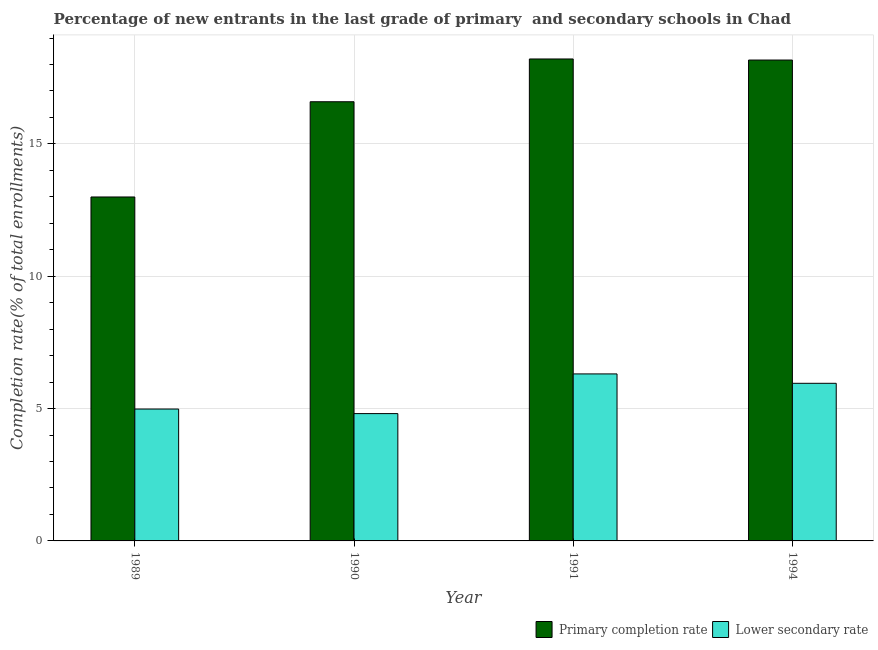How many different coloured bars are there?
Offer a terse response. 2. How many groups of bars are there?
Ensure brevity in your answer.  4. Are the number of bars per tick equal to the number of legend labels?
Give a very brief answer. Yes. How many bars are there on the 2nd tick from the left?
Make the answer very short. 2. How many bars are there on the 2nd tick from the right?
Keep it short and to the point. 2. What is the label of the 3rd group of bars from the left?
Offer a very short reply. 1991. What is the completion rate in primary schools in 1989?
Give a very brief answer. 13. Across all years, what is the maximum completion rate in secondary schools?
Offer a terse response. 6.31. Across all years, what is the minimum completion rate in secondary schools?
Your answer should be compact. 4.81. In which year was the completion rate in secondary schools maximum?
Give a very brief answer. 1991. In which year was the completion rate in secondary schools minimum?
Offer a very short reply. 1990. What is the total completion rate in primary schools in the graph?
Provide a succinct answer. 65.97. What is the difference between the completion rate in secondary schools in 1989 and that in 1994?
Keep it short and to the point. -0.97. What is the difference between the completion rate in primary schools in 1990 and the completion rate in secondary schools in 1991?
Your answer should be compact. -1.62. What is the average completion rate in secondary schools per year?
Provide a short and direct response. 5.51. In how many years, is the completion rate in secondary schools greater than 16 %?
Provide a succinct answer. 0. What is the ratio of the completion rate in secondary schools in 1989 to that in 1990?
Ensure brevity in your answer.  1.04. Is the difference between the completion rate in primary schools in 1990 and 1994 greater than the difference between the completion rate in secondary schools in 1990 and 1994?
Your response must be concise. No. What is the difference between the highest and the second highest completion rate in secondary schools?
Provide a short and direct response. 0.36. What is the difference between the highest and the lowest completion rate in primary schools?
Make the answer very short. 5.21. In how many years, is the completion rate in primary schools greater than the average completion rate in primary schools taken over all years?
Ensure brevity in your answer.  3. Is the sum of the completion rate in primary schools in 1989 and 1990 greater than the maximum completion rate in secondary schools across all years?
Your answer should be very brief. Yes. What does the 2nd bar from the left in 1994 represents?
Your answer should be compact. Lower secondary rate. What does the 1st bar from the right in 1994 represents?
Keep it short and to the point. Lower secondary rate. How many bars are there?
Provide a short and direct response. 8. Are all the bars in the graph horizontal?
Give a very brief answer. No. How many years are there in the graph?
Make the answer very short. 4. What is the difference between two consecutive major ticks on the Y-axis?
Your response must be concise. 5. Are the values on the major ticks of Y-axis written in scientific E-notation?
Make the answer very short. No. Does the graph contain any zero values?
Offer a terse response. No. Where does the legend appear in the graph?
Provide a short and direct response. Bottom right. How many legend labels are there?
Your answer should be compact. 2. What is the title of the graph?
Your answer should be very brief. Percentage of new entrants in the last grade of primary  and secondary schools in Chad. Does "Excluding technical cooperation" appear as one of the legend labels in the graph?
Provide a short and direct response. No. What is the label or title of the X-axis?
Give a very brief answer. Year. What is the label or title of the Y-axis?
Ensure brevity in your answer.  Completion rate(% of total enrollments). What is the Completion rate(% of total enrollments) of Primary completion rate in 1989?
Your answer should be compact. 13. What is the Completion rate(% of total enrollments) of Lower secondary rate in 1989?
Your answer should be compact. 4.98. What is the Completion rate(% of total enrollments) of Primary completion rate in 1990?
Your answer should be very brief. 16.59. What is the Completion rate(% of total enrollments) in Lower secondary rate in 1990?
Your answer should be very brief. 4.81. What is the Completion rate(% of total enrollments) in Primary completion rate in 1991?
Provide a succinct answer. 18.21. What is the Completion rate(% of total enrollments) in Lower secondary rate in 1991?
Keep it short and to the point. 6.31. What is the Completion rate(% of total enrollments) in Primary completion rate in 1994?
Keep it short and to the point. 18.17. What is the Completion rate(% of total enrollments) of Lower secondary rate in 1994?
Keep it short and to the point. 5.96. Across all years, what is the maximum Completion rate(% of total enrollments) of Primary completion rate?
Offer a terse response. 18.21. Across all years, what is the maximum Completion rate(% of total enrollments) of Lower secondary rate?
Provide a short and direct response. 6.31. Across all years, what is the minimum Completion rate(% of total enrollments) of Primary completion rate?
Provide a succinct answer. 13. Across all years, what is the minimum Completion rate(% of total enrollments) in Lower secondary rate?
Provide a succinct answer. 4.81. What is the total Completion rate(% of total enrollments) in Primary completion rate in the graph?
Keep it short and to the point. 65.97. What is the total Completion rate(% of total enrollments) of Lower secondary rate in the graph?
Keep it short and to the point. 22.06. What is the difference between the Completion rate(% of total enrollments) in Primary completion rate in 1989 and that in 1990?
Ensure brevity in your answer.  -3.6. What is the difference between the Completion rate(% of total enrollments) of Lower secondary rate in 1989 and that in 1990?
Provide a short and direct response. 0.17. What is the difference between the Completion rate(% of total enrollments) of Primary completion rate in 1989 and that in 1991?
Ensure brevity in your answer.  -5.21. What is the difference between the Completion rate(% of total enrollments) of Lower secondary rate in 1989 and that in 1991?
Provide a short and direct response. -1.33. What is the difference between the Completion rate(% of total enrollments) in Primary completion rate in 1989 and that in 1994?
Provide a short and direct response. -5.17. What is the difference between the Completion rate(% of total enrollments) in Lower secondary rate in 1989 and that in 1994?
Your answer should be compact. -0.97. What is the difference between the Completion rate(% of total enrollments) in Primary completion rate in 1990 and that in 1991?
Your answer should be very brief. -1.62. What is the difference between the Completion rate(% of total enrollments) of Lower secondary rate in 1990 and that in 1991?
Provide a short and direct response. -1.5. What is the difference between the Completion rate(% of total enrollments) of Primary completion rate in 1990 and that in 1994?
Ensure brevity in your answer.  -1.58. What is the difference between the Completion rate(% of total enrollments) in Lower secondary rate in 1990 and that in 1994?
Provide a succinct answer. -1.14. What is the difference between the Completion rate(% of total enrollments) of Primary completion rate in 1991 and that in 1994?
Keep it short and to the point. 0.04. What is the difference between the Completion rate(% of total enrollments) in Lower secondary rate in 1991 and that in 1994?
Provide a succinct answer. 0.36. What is the difference between the Completion rate(% of total enrollments) in Primary completion rate in 1989 and the Completion rate(% of total enrollments) in Lower secondary rate in 1990?
Keep it short and to the point. 8.18. What is the difference between the Completion rate(% of total enrollments) of Primary completion rate in 1989 and the Completion rate(% of total enrollments) of Lower secondary rate in 1991?
Ensure brevity in your answer.  6.68. What is the difference between the Completion rate(% of total enrollments) in Primary completion rate in 1989 and the Completion rate(% of total enrollments) in Lower secondary rate in 1994?
Provide a succinct answer. 7.04. What is the difference between the Completion rate(% of total enrollments) of Primary completion rate in 1990 and the Completion rate(% of total enrollments) of Lower secondary rate in 1991?
Your answer should be very brief. 10.28. What is the difference between the Completion rate(% of total enrollments) of Primary completion rate in 1990 and the Completion rate(% of total enrollments) of Lower secondary rate in 1994?
Your response must be concise. 10.64. What is the difference between the Completion rate(% of total enrollments) in Primary completion rate in 1991 and the Completion rate(% of total enrollments) in Lower secondary rate in 1994?
Provide a short and direct response. 12.25. What is the average Completion rate(% of total enrollments) of Primary completion rate per year?
Give a very brief answer. 16.49. What is the average Completion rate(% of total enrollments) in Lower secondary rate per year?
Offer a terse response. 5.51. In the year 1989, what is the difference between the Completion rate(% of total enrollments) in Primary completion rate and Completion rate(% of total enrollments) in Lower secondary rate?
Give a very brief answer. 8.01. In the year 1990, what is the difference between the Completion rate(% of total enrollments) in Primary completion rate and Completion rate(% of total enrollments) in Lower secondary rate?
Your answer should be very brief. 11.78. In the year 1991, what is the difference between the Completion rate(% of total enrollments) in Primary completion rate and Completion rate(% of total enrollments) in Lower secondary rate?
Offer a very short reply. 11.9. In the year 1994, what is the difference between the Completion rate(% of total enrollments) in Primary completion rate and Completion rate(% of total enrollments) in Lower secondary rate?
Offer a terse response. 12.21. What is the ratio of the Completion rate(% of total enrollments) in Primary completion rate in 1989 to that in 1990?
Your answer should be very brief. 0.78. What is the ratio of the Completion rate(% of total enrollments) in Lower secondary rate in 1989 to that in 1990?
Provide a short and direct response. 1.04. What is the ratio of the Completion rate(% of total enrollments) of Primary completion rate in 1989 to that in 1991?
Your answer should be very brief. 0.71. What is the ratio of the Completion rate(% of total enrollments) in Lower secondary rate in 1989 to that in 1991?
Your answer should be very brief. 0.79. What is the ratio of the Completion rate(% of total enrollments) of Primary completion rate in 1989 to that in 1994?
Your answer should be compact. 0.72. What is the ratio of the Completion rate(% of total enrollments) of Lower secondary rate in 1989 to that in 1994?
Offer a very short reply. 0.84. What is the ratio of the Completion rate(% of total enrollments) of Primary completion rate in 1990 to that in 1991?
Your answer should be very brief. 0.91. What is the ratio of the Completion rate(% of total enrollments) in Lower secondary rate in 1990 to that in 1991?
Your answer should be very brief. 0.76. What is the ratio of the Completion rate(% of total enrollments) in Primary completion rate in 1990 to that in 1994?
Offer a very short reply. 0.91. What is the ratio of the Completion rate(% of total enrollments) of Lower secondary rate in 1990 to that in 1994?
Your answer should be compact. 0.81. What is the ratio of the Completion rate(% of total enrollments) of Lower secondary rate in 1991 to that in 1994?
Offer a very short reply. 1.06. What is the difference between the highest and the second highest Completion rate(% of total enrollments) in Primary completion rate?
Keep it short and to the point. 0.04. What is the difference between the highest and the second highest Completion rate(% of total enrollments) in Lower secondary rate?
Offer a terse response. 0.36. What is the difference between the highest and the lowest Completion rate(% of total enrollments) in Primary completion rate?
Keep it short and to the point. 5.21. What is the difference between the highest and the lowest Completion rate(% of total enrollments) in Lower secondary rate?
Your response must be concise. 1.5. 